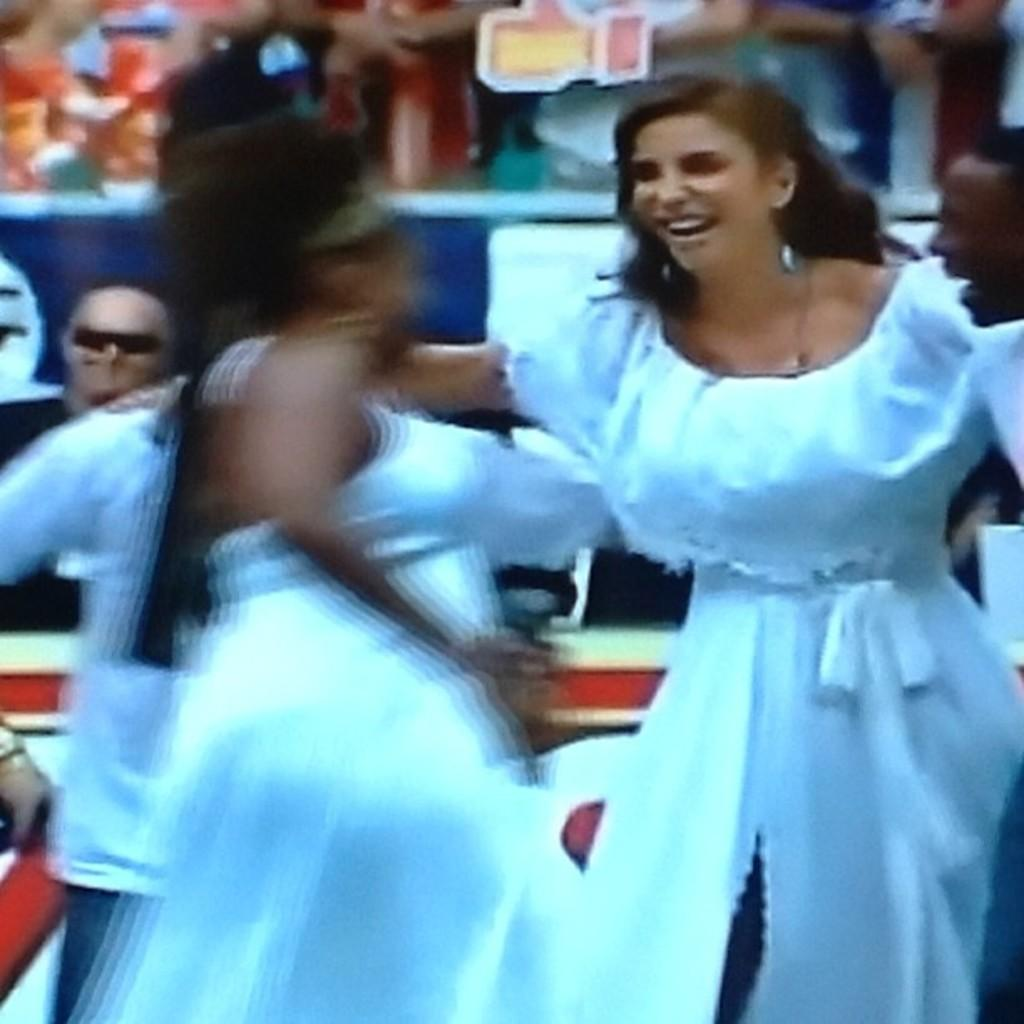Who or what is present in the image? There are people in the image. Can you describe the background of the image? The background of the image is blurred. Where can the basket be found in the image? There is no basket present in the image. What assistance can be provided by the people in the image? The image does not provide any information about the people's actions or intentions, so it is impossible to determine what assistance they might provide. 